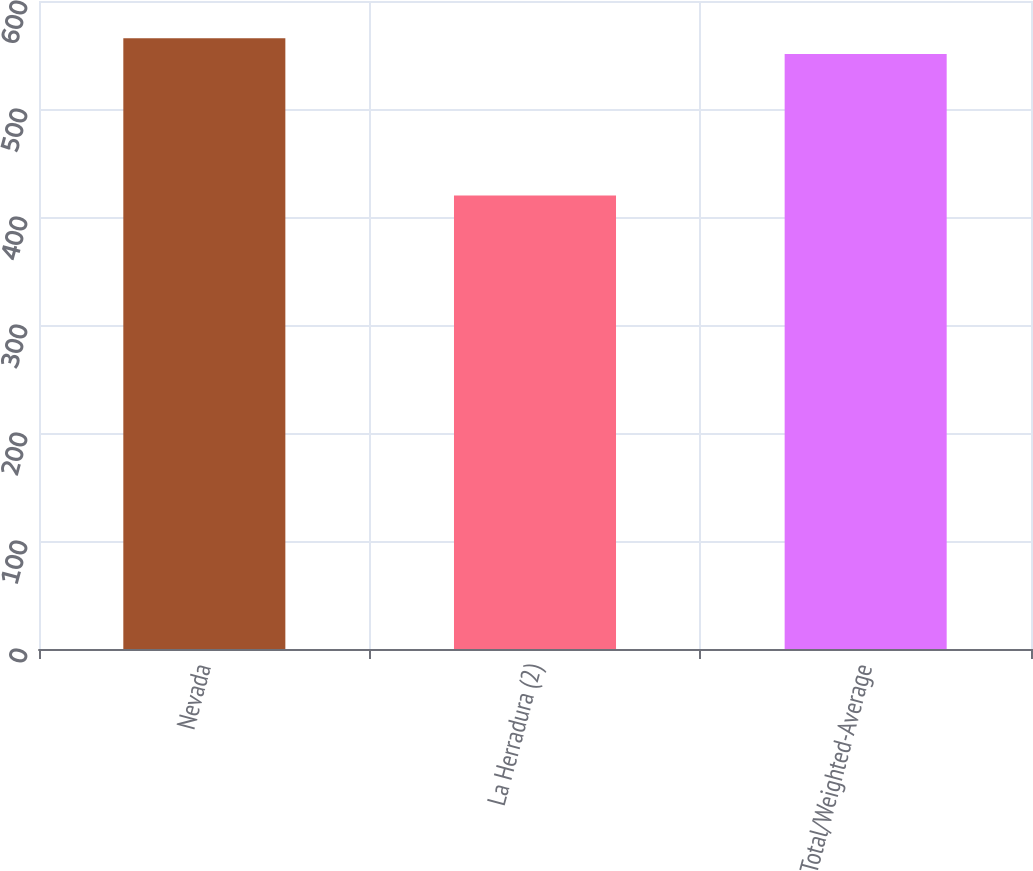Convert chart. <chart><loc_0><loc_0><loc_500><loc_500><bar_chart><fcel>Nevada<fcel>La Herradura (2)<fcel>Total/Weighted-Average<nl><fcel>565.5<fcel>420<fcel>551<nl></chart> 